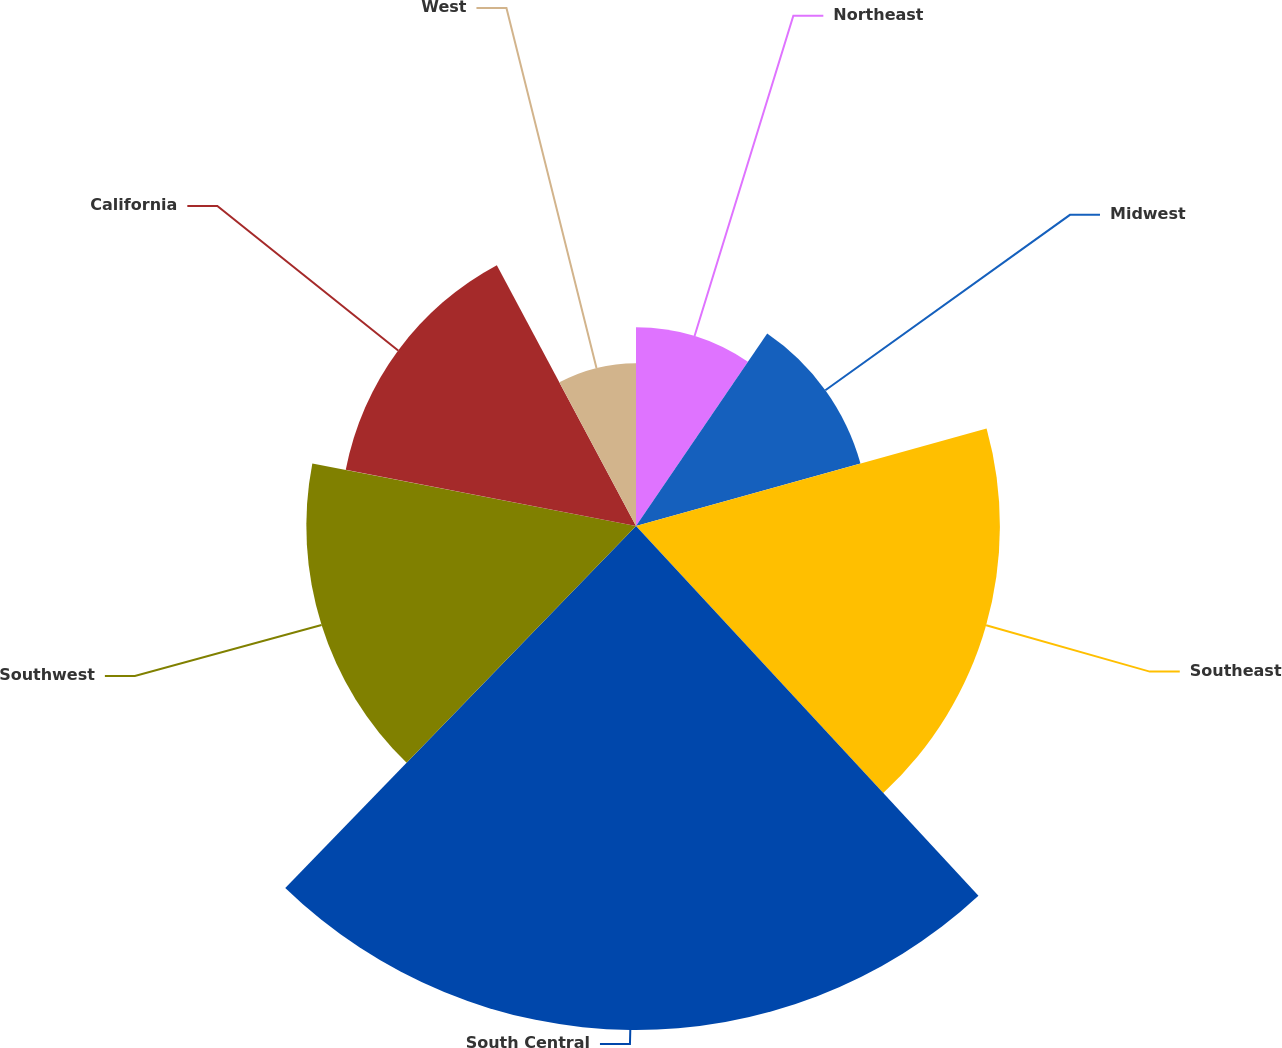Convert chart to OTSL. <chart><loc_0><loc_0><loc_500><loc_500><pie_chart><fcel>Northeast<fcel>Midwest<fcel>Southeast<fcel>South Central<fcel>Southwest<fcel>California<fcel>West<nl><fcel>9.52%<fcel>11.16%<fcel>17.43%<fcel>24.14%<fcel>15.79%<fcel>14.16%<fcel>7.8%<nl></chart> 